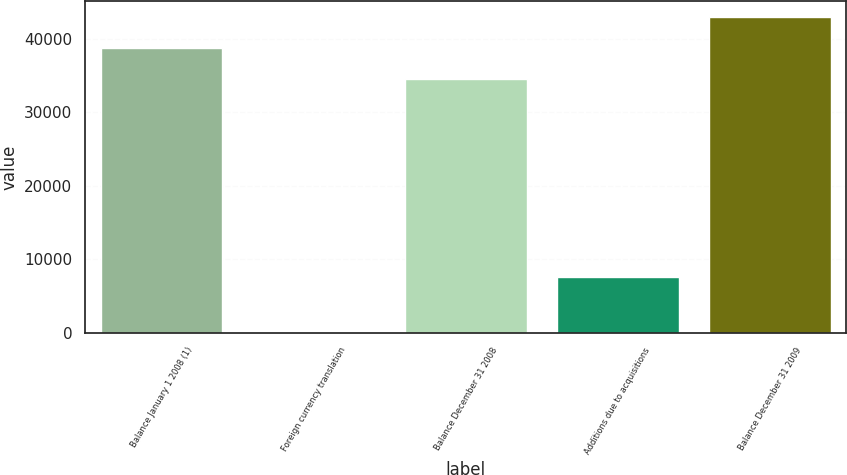Convert chart to OTSL. <chart><loc_0><loc_0><loc_500><loc_500><bar_chart><fcel>Balance January 1 2008 (1)<fcel>Foreign currency translation<fcel>Balance December 31 2008<fcel>Additions due to acquisitions<fcel>Balance December 31 2009<nl><fcel>38741.1<fcel>107<fcel>34528<fcel>7637<fcel>42954.2<nl></chart> 